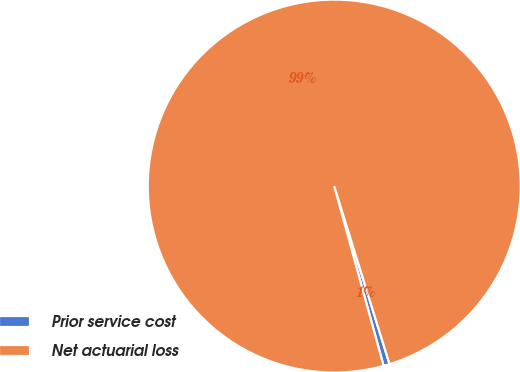Convert chart. <chart><loc_0><loc_0><loc_500><loc_500><pie_chart><fcel>Prior service cost<fcel>Net actuarial loss<nl><fcel>0.53%<fcel>99.47%<nl></chart> 